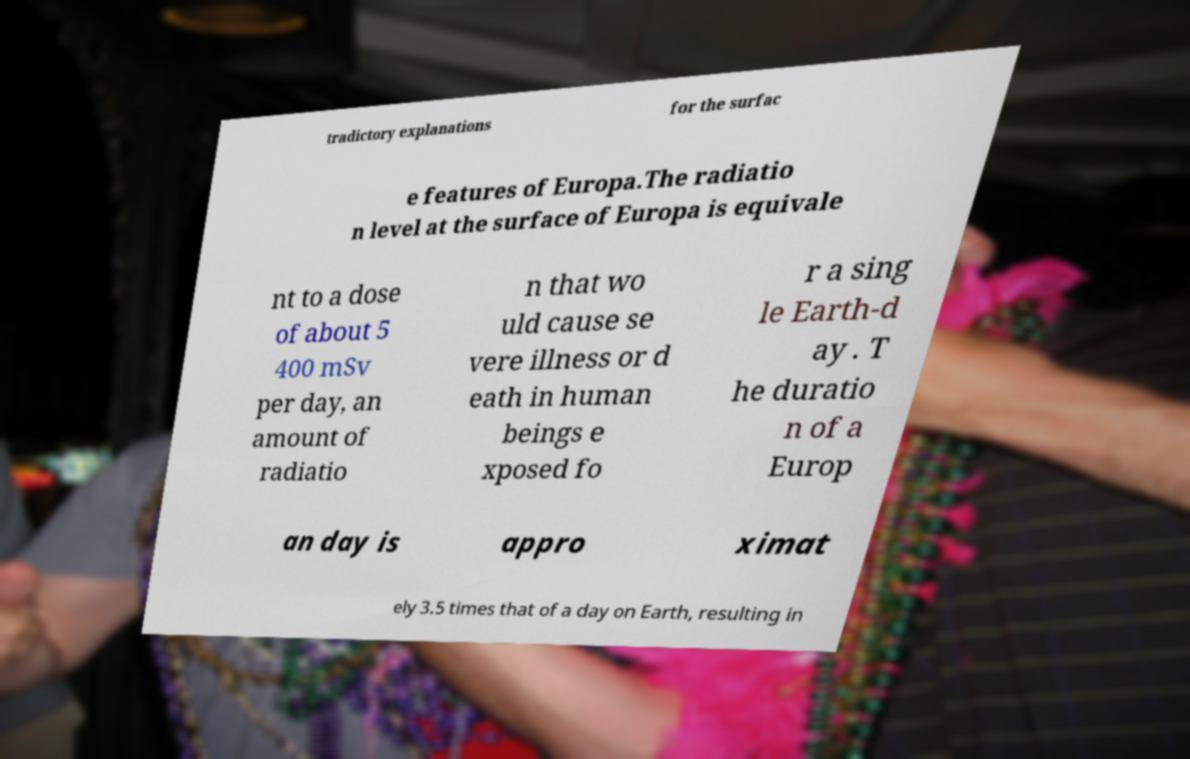Could you assist in decoding the text presented in this image and type it out clearly? tradictory explanations for the surfac e features of Europa.The radiatio n level at the surface of Europa is equivale nt to a dose of about 5 400 mSv per day, an amount of radiatio n that wo uld cause se vere illness or d eath in human beings e xposed fo r a sing le Earth-d ay . T he duratio n of a Europ an day is appro ximat ely 3.5 times that of a day on Earth, resulting in 